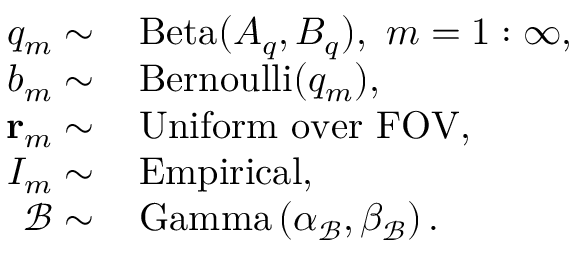<formula> <loc_0><loc_0><loc_500><loc_500>\begin{array} { r l } { q _ { m } \sim } & \, B e t a ( A _ { q } , B _ { q } ) , \, m = 1 \colon \infty , } \\ { b _ { m } \sim } & \, B e r n o u l l i ( q _ { m } ) , } \\ { r _ { m } \sim } & \, U n i f o r m \, o v e r \, F O V , } \\ { I _ { m } \sim } & \, E m p i r i c a l , } \\ { \mathcal { B } \sim } & \, G a m m a \left ( \alpha _ { \mathcal { B } } , \beta _ { \mathcal { B } } \right ) . } \end{array}</formula> 